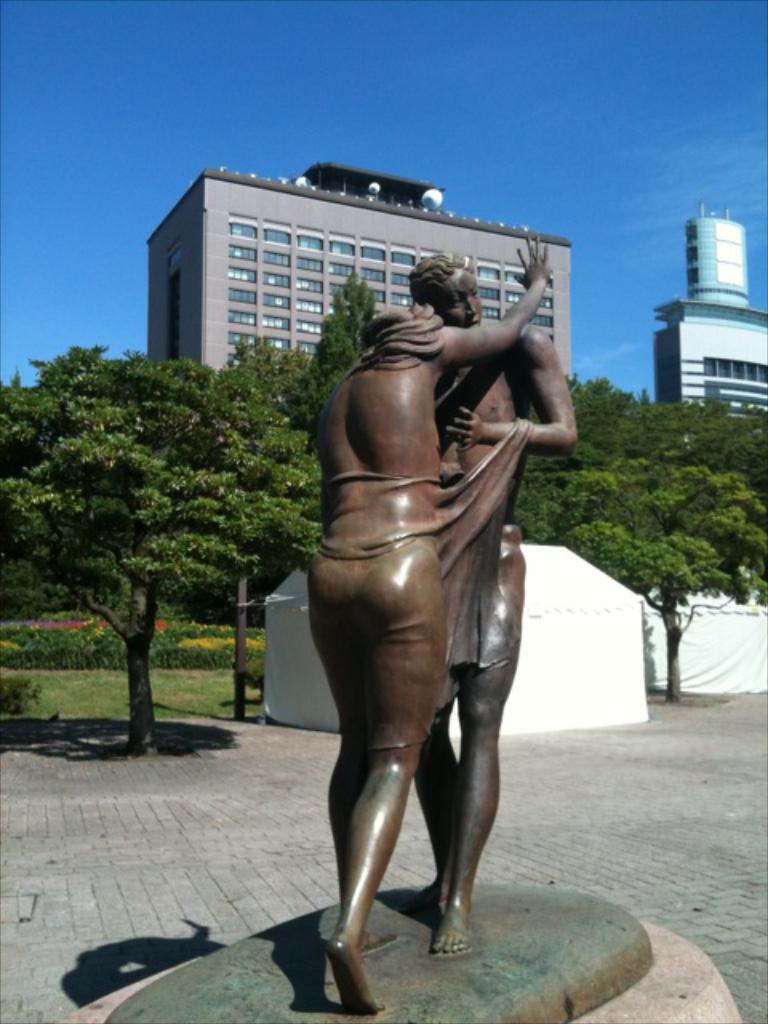How many people are in the image? There are two persons depicted on a rock structure in the image. What can be seen in the background of the image? There are buildings, trees, two camps, and the sky visible in the background of the image. Where is the rabbit hiding in the image? There is no rabbit present in the image. What type of amusement can be seen in the image? There is no amusement depicted in the image; it features two persons on a rock structure, buildings, trees, camps, and the sky. 